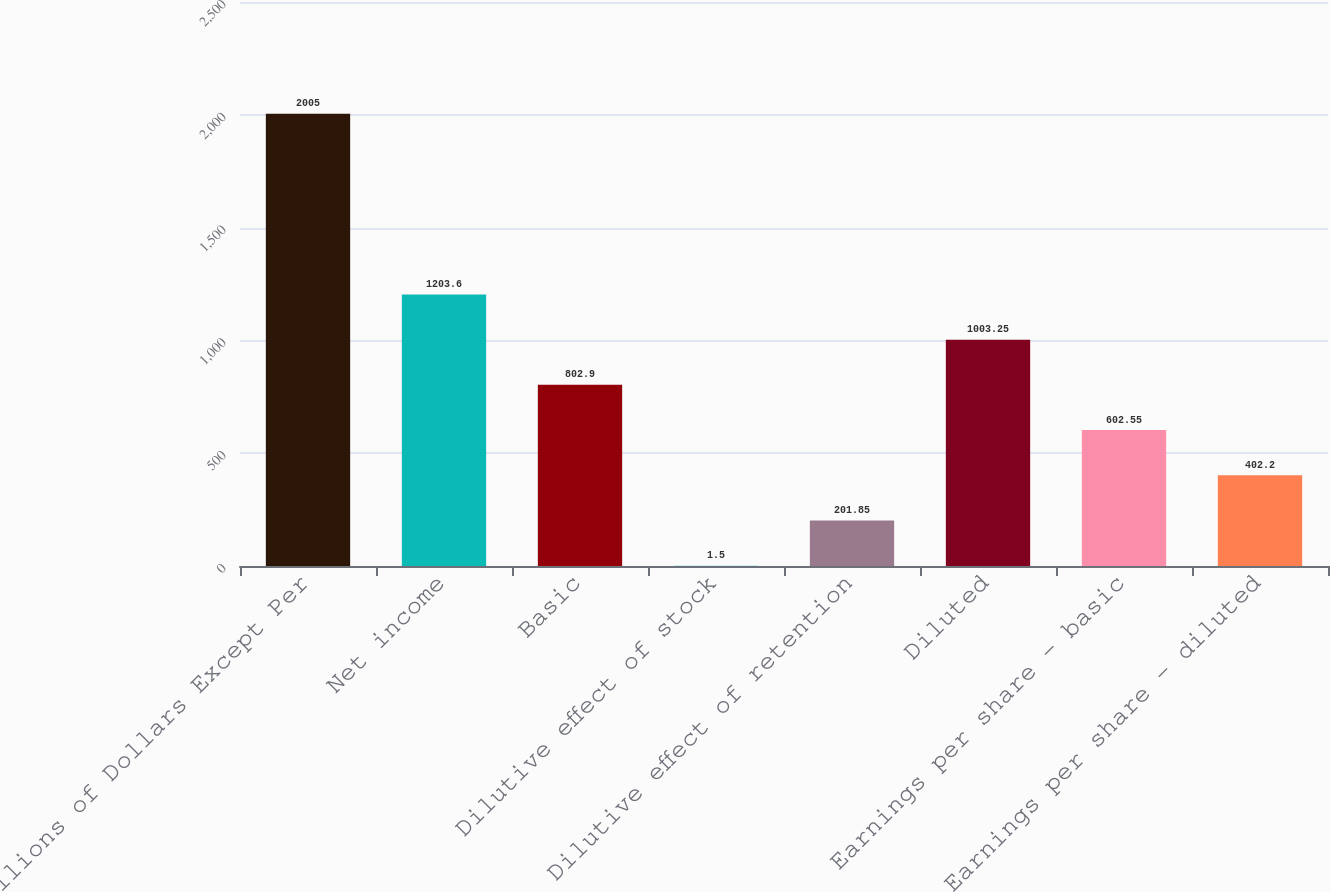<chart> <loc_0><loc_0><loc_500><loc_500><bar_chart><fcel>Millions of Dollars Except Per<fcel>Net income<fcel>Basic<fcel>Dilutive effect of stock<fcel>Dilutive effect of retention<fcel>Diluted<fcel>Earnings per share - basic<fcel>Earnings per share - diluted<nl><fcel>2005<fcel>1203.6<fcel>802.9<fcel>1.5<fcel>201.85<fcel>1003.25<fcel>602.55<fcel>402.2<nl></chart> 